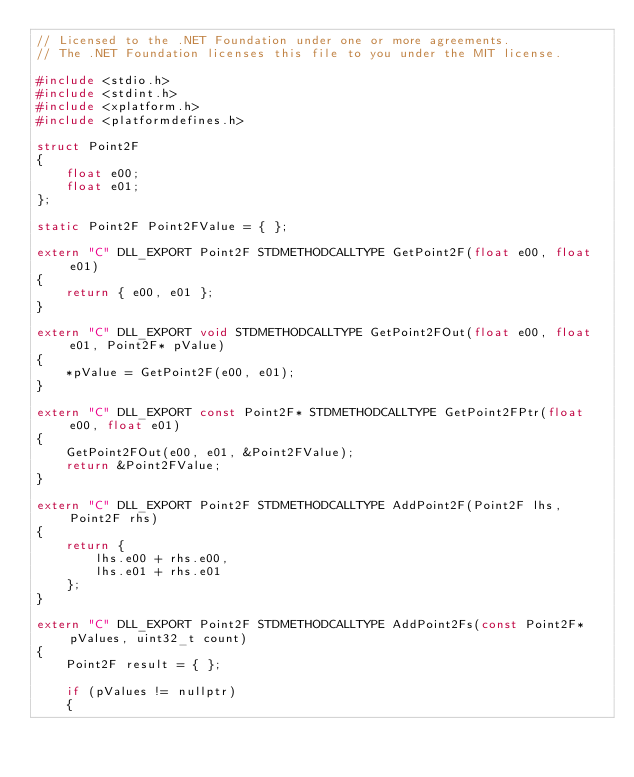<code> <loc_0><loc_0><loc_500><loc_500><_C++_>// Licensed to the .NET Foundation under one or more agreements.
// The .NET Foundation licenses this file to you under the MIT license.

#include <stdio.h>
#include <stdint.h>
#include <xplatform.h>
#include <platformdefines.h>

struct Point2F
{
    float e00;
    float e01;
};

static Point2F Point2FValue = { };

extern "C" DLL_EXPORT Point2F STDMETHODCALLTYPE GetPoint2F(float e00, float e01)
{
    return { e00, e01 };
}

extern "C" DLL_EXPORT void STDMETHODCALLTYPE GetPoint2FOut(float e00, float e01, Point2F* pValue)
{
    *pValue = GetPoint2F(e00, e01);
}

extern "C" DLL_EXPORT const Point2F* STDMETHODCALLTYPE GetPoint2FPtr(float e00, float e01)
{
    GetPoint2FOut(e00, e01, &Point2FValue);
    return &Point2FValue;
}

extern "C" DLL_EXPORT Point2F STDMETHODCALLTYPE AddPoint2F(Point2F lhs, Point2F rhs)
{
    return {
        lhs.e00 + rhs.e00,
        lhs.e01 + rhs.e01
    };
}

extern "C" DLL_EXPORT Point2F STDMETHODCALLTYPE AddPoint2Fs(const Point2F* pValues, uint32_t count)
{
    Point2F result = { };

    if (pValues != nullptr)
    {</code> 